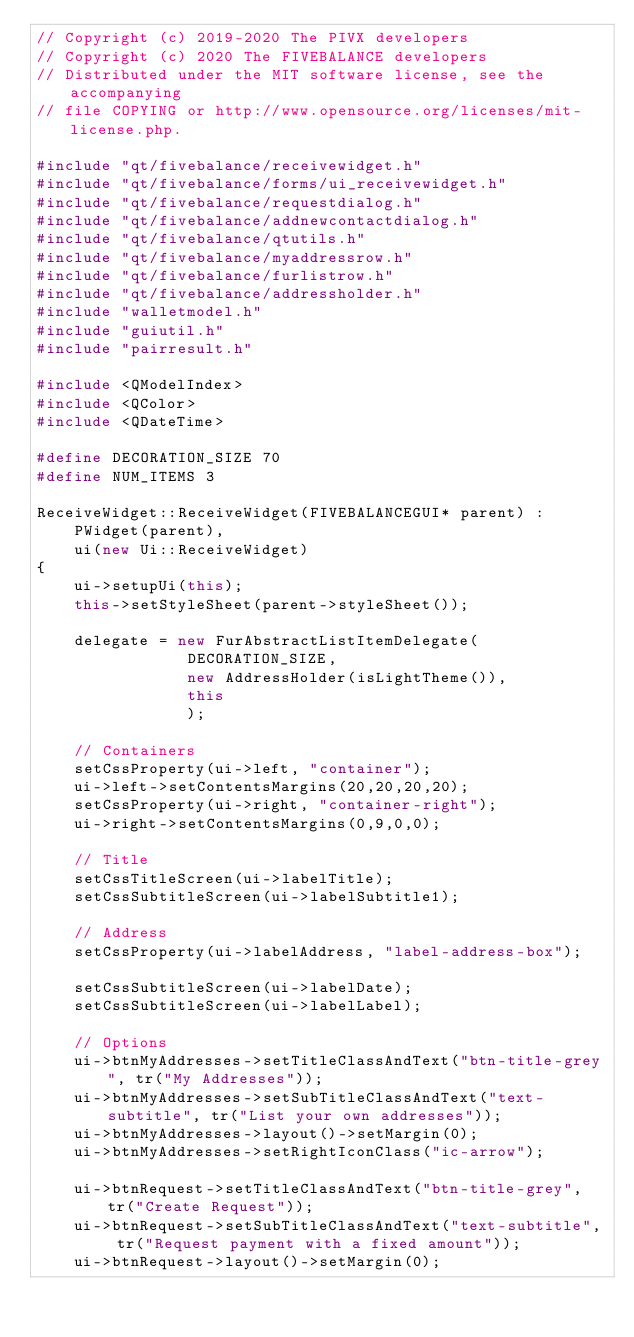Convert code to text. <code><loc_0><loc_0><loc_500><loc_500><_C++_>// Copyright (c) 2019-2020 The PIVX developers
// Copyright (c) 2020 The FIVEBALANCE developers
// Distributed under the MIT software license, see the accompanying
// file COPYING or http://www.opensource.org/licenses/mit-license.php.

#include "qt/fivebalance/receivewidget.h"
#include "qt/fivebalance/forms/ui_receivewidget.h"
#include "qt/fivebalance/requestdialog.h"
#include "qt/fivebalance/addnewcontactdialog.h"
#include "qt/fivebalance/qtutils.h"
#include "qt/fivebalance/myaddressrow.h"
#include "qt/fivebalance/furlistrow.h"
#include "qt/fivebalance/addressholder.h"
#include "walletmodel.h"
#include "guiutil.h"
#include "pairresult.h"

#include <QModelIndex>
#include <QColor>
#include <QDateTime>

#define DECORATION_SIZE 70
#define NUM_ITEMS 3

ReceiveWidget::ReceiveWidget(FIVEBALANCEGUI* parent) :
    PWidget(parent),
    ui(new Ui::ReceiveWidget)
{
    ui->setupUi(this);
    this->setStyleSheet(parent->styleSheet());

    delegate = new FurAbstractListItemDelegate(
                DECORATION_SIZE,
                new AddressHolder(isLightTheme()),
                this
                );

    // Containers
    setCssProperty(ui->left, "container");
    ui->left->setContentsMargins(20,20,20,20);
    setCssProperty(ui->right, "container-right");
    ui->right->setContentsMargins(0,9,0,0);

    // Title
    setCssTitleScreen(ui->labelTitle);
    setCssSubtitleScreen(ui->labelSubtitle1);

    // Address
    setCssProperty(ui->labelAddress, "label-address-box");

    setCssSubtitleScreen(ui->labelDate);
    setCssSubtitleScreen(ui->labelLabel);

    // Options
    ui->btnMyAddresses->setTitleClassAndText("btn-title-grey", tr("My Addresses"));
    ui->btnMyAddresses->setSubTitleClassAndText("text-subtitle", tr("List your own addresses"));
    ui->btnMyAddresses->layout()->setMargin(0);
    ui->btnMyAddresses->setRightIconClass("ic-arrow");

    ui->btnRequest->setTitleClassAndText("btn-title-grey", tr("Create Request"));
    ui->btnRequest->setSubTitleClassAndText("text-subtitle", tr("Request payment with a fixed amount"));
    ui->btnRequest->layout()->setMargin(0);
</code> 